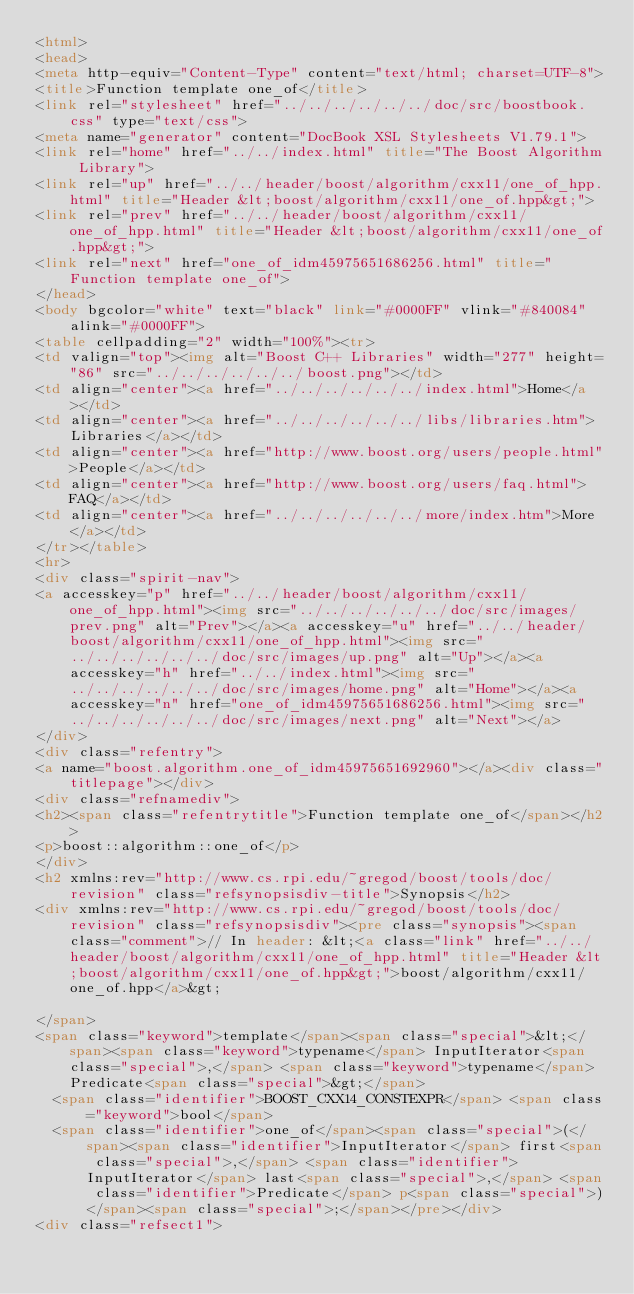<code> <loc_0><loc_0><loc_500><loc_500><_HTML_><html>
<head>
<meta http-equiv="Content-Type" content="text/html; charset=UTF-8">
<title>Function template one_of</title>
<link rel="stylesheet" href="../../../../../../doc/src/boostbook.css" type="text/css">
<meta name="generator" content="DocBook XSL Stylesheets V1.79.1">
<link rel="home" href="../../index.html" title="The Boost Algorithm Library">
<link rel="up" href="../../header/boost/algorithm/cxx11/one_of_hpp.html" title="Header &lt;boost/algorithm/cxx11/one_of.hpp&gt;">
<link rel="prev" href="../../header/boost/algorithm/cxx11/one_of_hpp.html" title="Header &lt;boost/algorithm/cxx11/one_of.hpp&gt;">
<link rel="next" href="one_of_idm45975651686256.html" title="Function template one_of">
</head>
<body bgcolor="white" text="black" link="#0000FF" vlink="#840084" alink="#0000FF">
<table cellpadding="2" width="100%"><tr>
<td valign="top"><img alt="Boost C++ Libraries" width="277" height="86" src="../../../../../../boost.png"></td>
<td align="center"><a href="../../../../../../index.html">Home</a></td>
<td align="center"><a href="../../../../../../libs/libraries.htm">Libraries</a></td>
<td align="center"><a href="http://www.boost.org/users/people.html">People</a></td>
<td align="center"><a href="http://www.boost.org/users/faq.html">FAQ</a></td>
<td align="center"><a href="../../../../../../more/index.htm">More</a></td>
</tr></table>
<hr>
<div class="spirit-nav">
<a accesskey="p" href="../../header/boost/algorithm/cxx11/one_of_hpp.html"><img src="../../../../../../doc/src/images/prev.png" alt="Prev"></a><a accesskey="u" href="../../header/boost/algorithm/cxx11/one_of_hpp.html"><img src="../../../../../../doc/src/images/up.png" alt="Up"></a><a accesskey="h" href="../../index.html"><img src="../../../../../../doc/src/images/home.png" alt="Home"></a><a accesskey="n" href="one_of_idm45975651686256.html"><img src="../../../../../../doc/src/images/next.png" alt="Next"></a>
</div>
<div class="refentry">
<a name="boost.algorithm.one_of_idm45975651692960"></a><div class="titlepage"></div>
<div class="refnamediv">
<h2><span class="refentrytitle">Function template one_of</span></h2>
<p>boost::algorithm::one_of</p>
</div>
<h2 xmlns:rev="http://www.cs.rpi.edu/~gregod/boost/tools/doc/revision" class="refsynopsisdiv-title">Synopsis</h2>
<div xmlns:rev="http://www.cs.rpi.edu/~gregod/boost/tools/doc/revision" class="refsynopsisdiv"><pre class="synopsis"><span class="comment">// In header: &lt;<a class="link" href="../../header/boost/algorithm/cxx11/one_of_hpp.html" title="Header &lt;boost/algorithm/cxx11/one_of.hpp&gt;">boost/algorithm/cxx11/one_of.hpp</a>&gt;

</span>
<span class="keyword">template</span><span class="special">&lt;</span><span class="keyword">typename</span> InputIterator<span class="special">,</span> <span class="keyword">typename</span> Predicate<span class="special">&gt;</span> 
  <span class="identifier">BOOST_CXX14_CONSTEXPR</span> <span class="keyword">bool</span> 
  <span class="identifier">one_of</span><span class="special">(</span><span class="identifier">InputIterator</span> first<span class="special">,</span> <span class="identifier">InputIterator</span> last<span class="special">,</span> <span class="identifier">Predicate</span> p<span class="special">)</span><span class="special">;</span></pre></div>
<div class="refsect1"></code> 